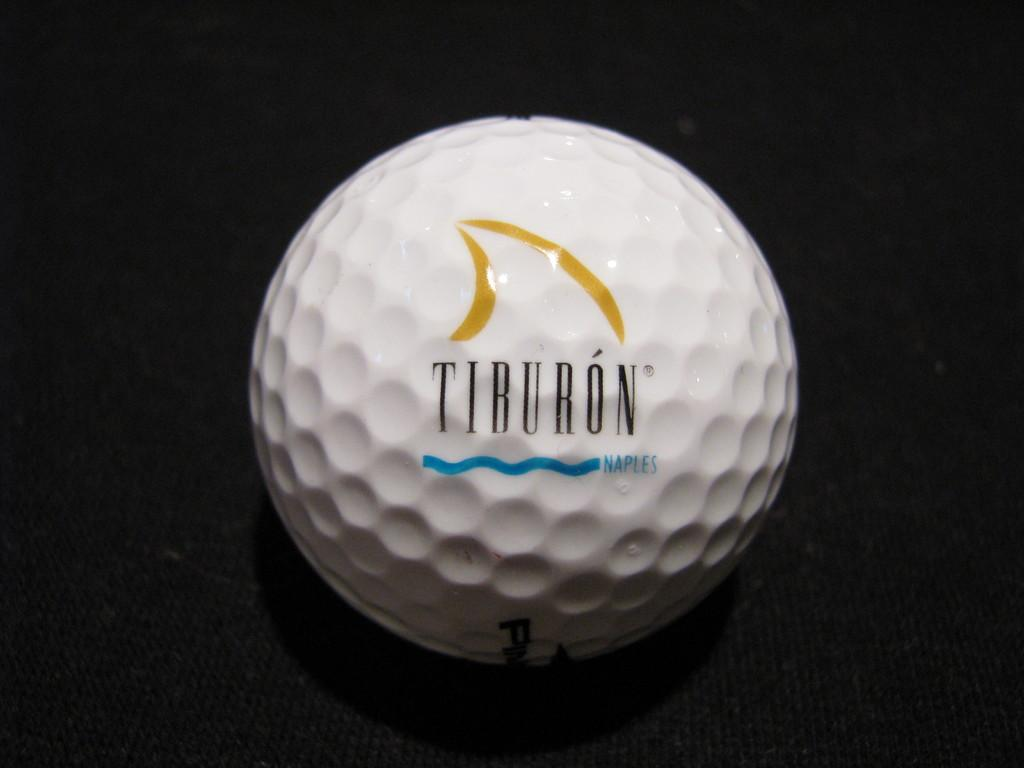<image>
Offer a succinct explanation of the picture presented. Black circle covering part of a Tiburon golfball. 